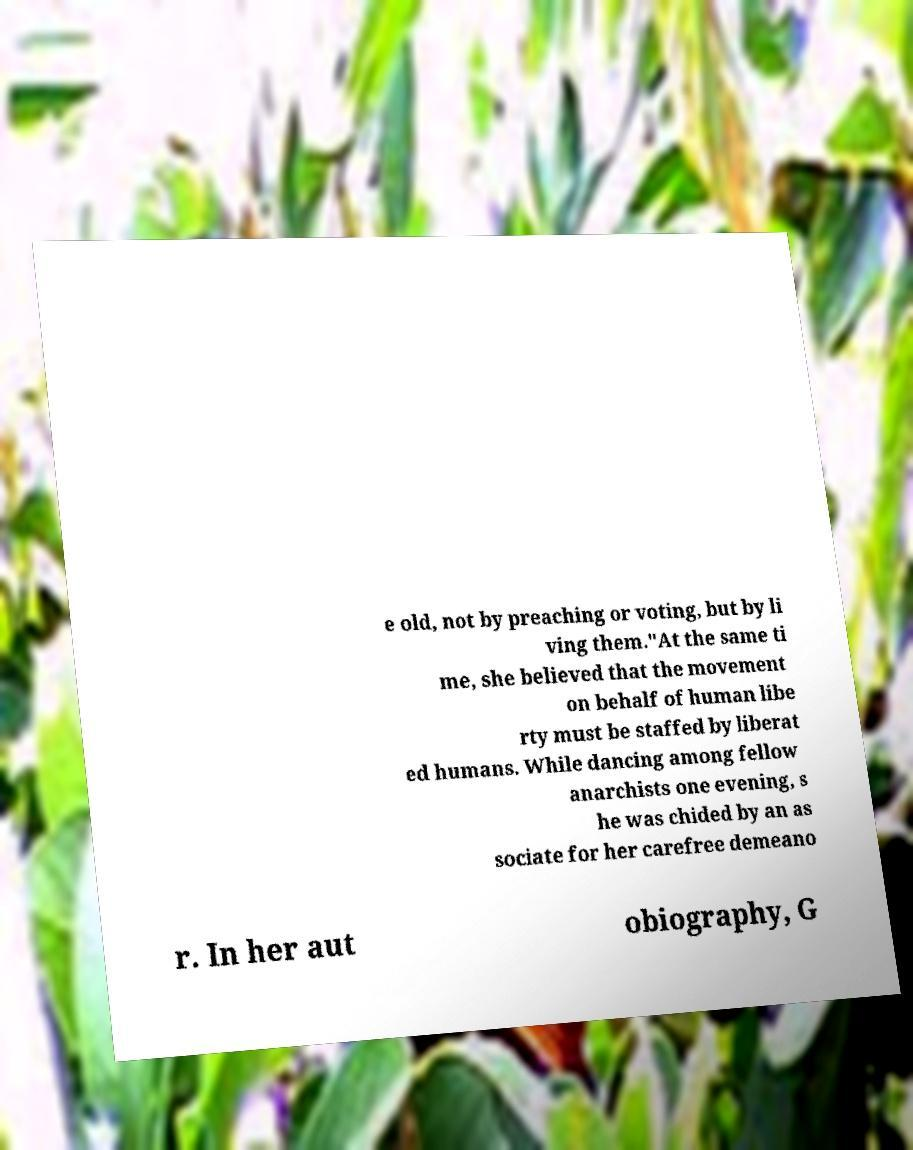Please read and relay the text visible in this image. What does it say? e old, not by preaching or voting, but by li ving them."At the same ti me, she believed that the movement on behalf of human libe rty must be staffed by liberat ed humans. While dancing among fellow anarchists one evening, s he was chided by an as sociate for her carefree demeano r. In her aut obiography, G 